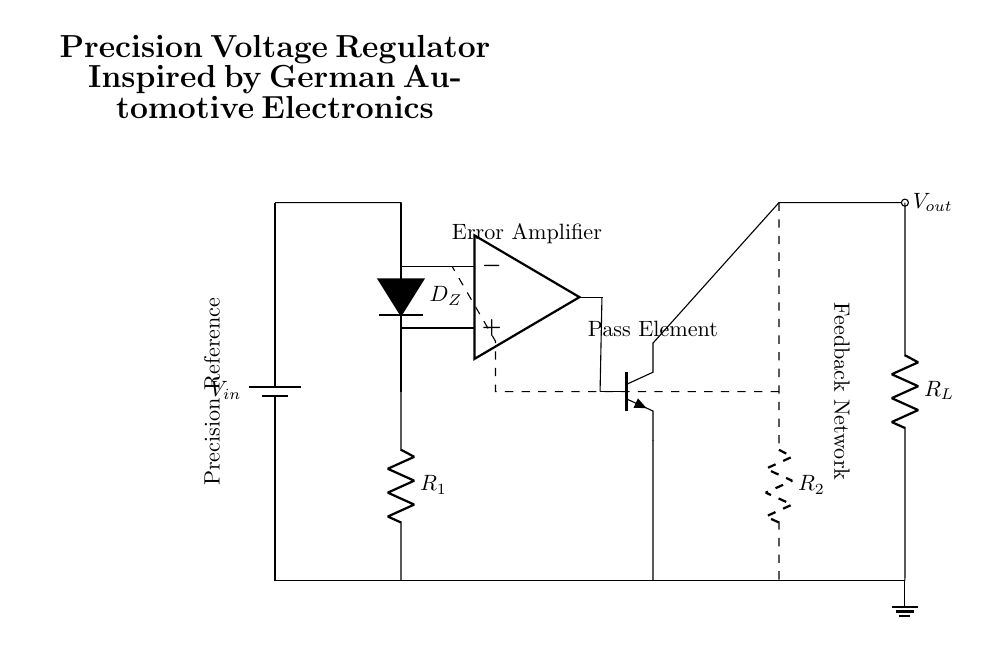What is the input voltage symbol in the circuit? The input voltage is represented by the symbol \( V_{in} \), which is shown as a battery in the circuit.
Answer: \( V_{in} \) What type of diode is used in the circuit? A Zener diode is indicated as \( D_Z \) in the circuit diagram, suggesting its primary role in voltage regulation.
Answer: Zener diode What is the role of the operational amplifier? The operational amplifier, labeled as the error amplifier, is used to compare the output voltage with the reference voltage, enabling precise regulation.
Answer: Error amplifier How many resistors are present in the circuit? There are two resistors in the circuit, \( R_1 \) and \( R_2 \), which help in setting the voltage and providing feedback for regulation.
Answer: 2 What is the purpose of the feedback network in this regulator? The feedback network connects the output back to the negative input of the operational amplifier, allowing for accurate voltage regulation by adjusting the pass element based on the output voltage.
Answer: Accurate voltage regulation What is the output voltage symbol in the circuit? The output voltage is denoted by the symbol \( V_{out} \), which shows where the regulated voltage is taken from.
Answer: \( V_{out} \) What type of transistor is used as the pass element? The pass element in this circuit is an NPN transistor, indicated by the symbol and functioning as the control element to manage the output voltage.
Answer: NPN transistor 